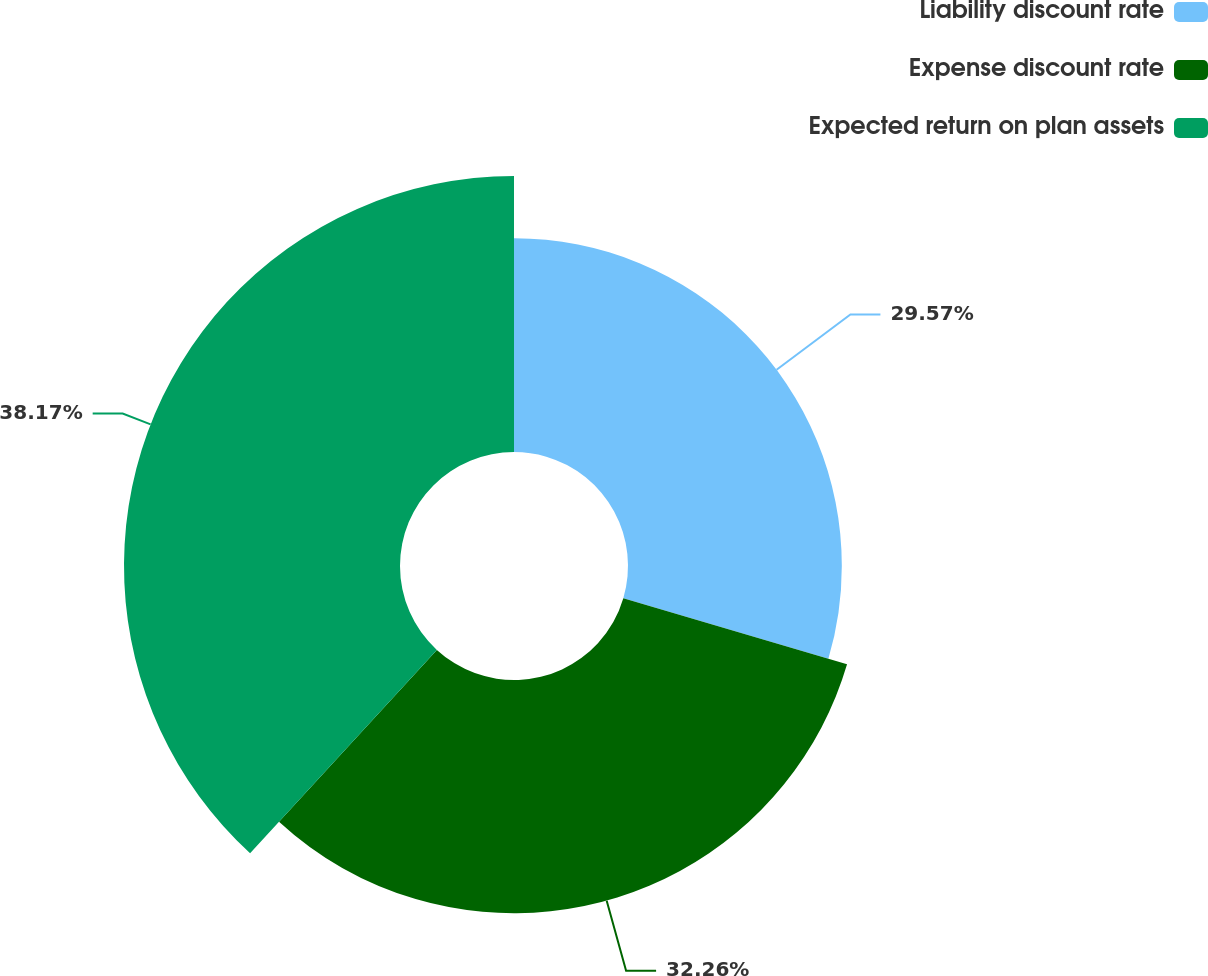Convert chart to OTSL. <chart><loc_0><loc_0><loc_500><loc_500><pie_chart><fcel>Liability discount rate<fcel>Expense discount rate<fcel>Expected return on plan assets<nl><fcel>29.57%<fcel>32.26%<fcel>38.17%<nl></chart> 